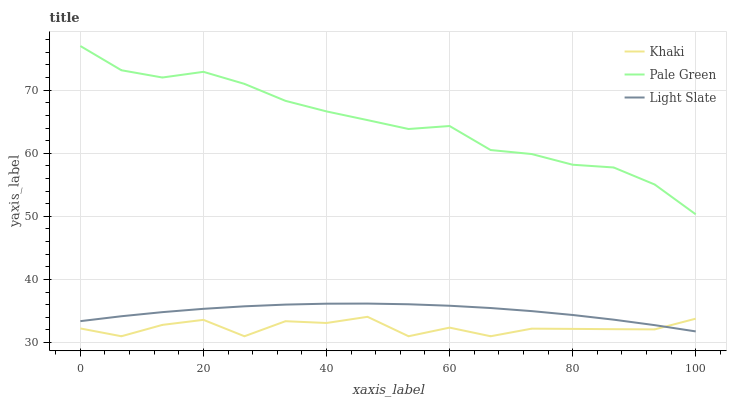Does Khaki have the minimum area under the curve?
Answer yes or no. Yes. Does Pale Green have the maximum area under the curve?
Answer yes or no. Yes. Does Pale Green have the minimum area under the curve?
Answer yes or no. No. Does Khaki have the maximum area under the curve?
Answer yes or no. No. Is Light Slate the smoothest?
Answer yes or no. Yes. Is Khaki the roughest?
Answer yes or no. Yes. Is Pale Green the smoothest?
Answer yes or no. No. Is Pale Green the roughest?
Answer yes or no. No. Does Khaki have the lowest value?
Answer yes or no. Yes. Does Pale Green have the lowest value?
Answer yes or no. No. Does Pale Green have the highest value?
Answer yes or no. Yes. Does Khaki have the highest value?
Answer yes or no. No. Is Light Slate less than Pale Green?
Answer yes or no. Yes. Is Pale Green greater than Khaki?
Answer yes or no. Yes. Does Khaki intersect Light Slate?
Answer yes or no. Yes. Is Khaki less than Light Slate?
Answer yes or no. No. Is Khaki greater than Light Slate?
Answer yes or no. No. Does Light Slate intersect Pale Green?
Answer yes or no. No. 